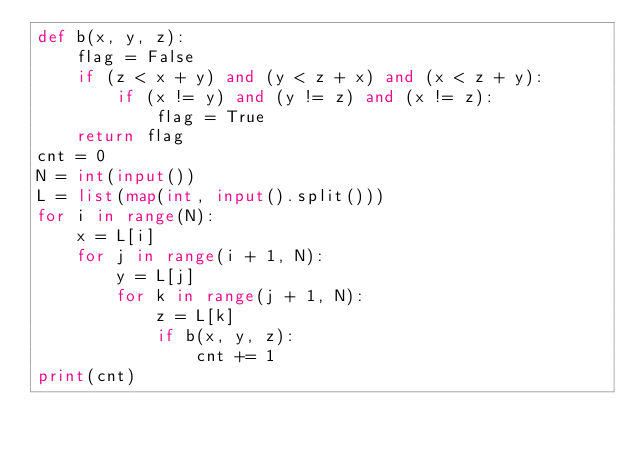<code> <loc_0><loc_0><loc_500><loc_500><_Python_>def b(x, y, z):
    flag = False
    if (z < x + y) and (y < z + x) and (x < z + y):
        if (x != y) and (y != z) and (x != z):
            flag = True
    return flag
cnt = 0
N = int(input())
L = list(map(int, input().split()))
for i in range(N):
    x = L[i]
    for j in range(i + 1, N):
        y = L[j]
        for k in range(j + 1, N):
            z = L[k]
            if b(x, y, z):
                cnt += 1
print(cnt)</code> 